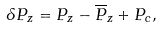Convert formula to latex. <formula><loc_0><loc_0><loc_500><loc_500>\delta P _ { z } = P _ { z } - \overline { P } _ { z } + P _ { c } ,</formula> 